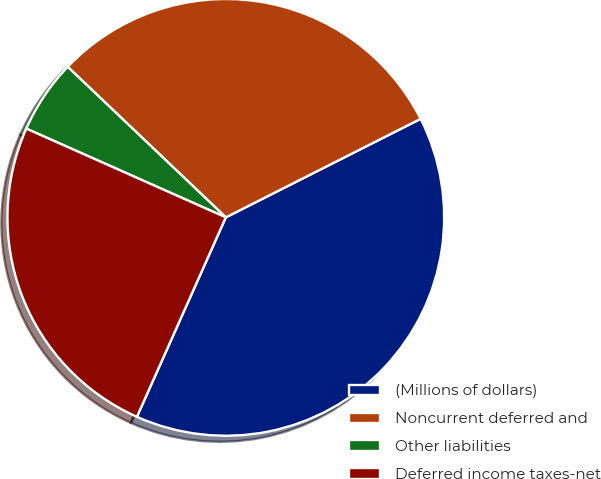<chart> <loc_0><loc_0><loc_500><loc_500><pie_chart><fcel>(Millions of dollars)<fcel>Noncurrent deferred and<fcel>Other liabilities<fcel>Deferred income taxes-net<nl><fcel>39.13%<fcel>30.44%<fcel>5.45%<fcel>24.99%<nl></chart> 